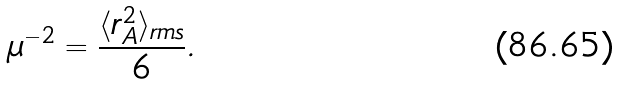<formula> <loc_0><loc_0><loc_500><loc_500>\mu ^ { - 2 } = \frac { \langle r ^ { 2 } _ { A } \rangle _ { r m s } } { 6 } .</formula> 